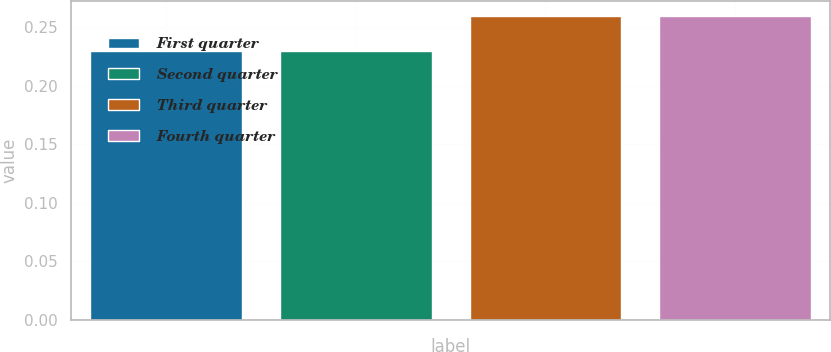Convert chart. <chart><loc_0><loc_0><loc_500><loc_500><bar_chart><fcel>First quarter<fcel>Second quarter<fcel>Third quarter<fcel>Fourth quarter<nl><fcel>0.23<fcel>0.23<fcel>0.26<fcel>0.26<nl></chart> 